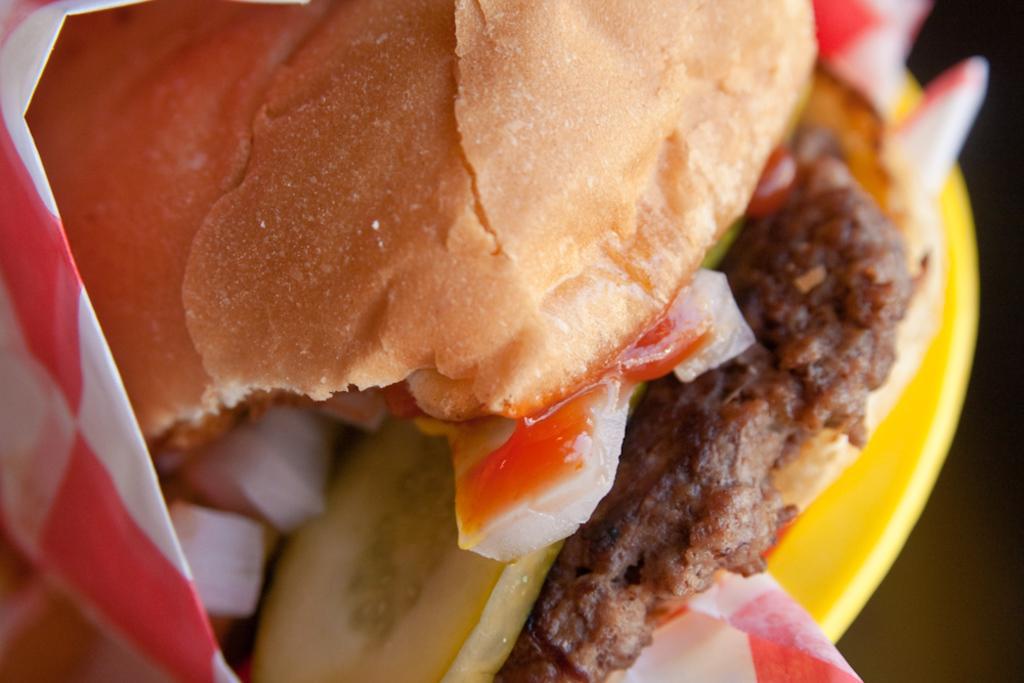How would you summarize this image in a sentence or two? In this image I can see food which is in brown, red color on the plate and the plate is in yellow color. 